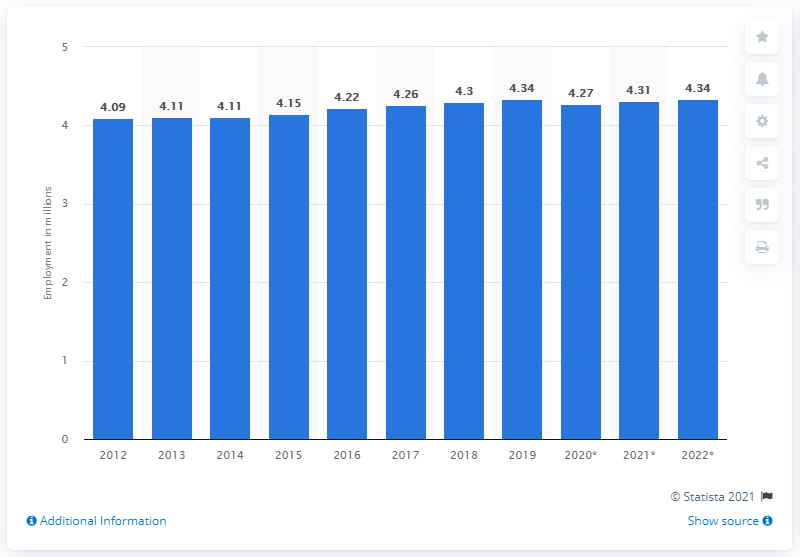Mention a couple of crucial points in this snapshot. In 2019, the number of people employed in Austria was 4.34 million. 